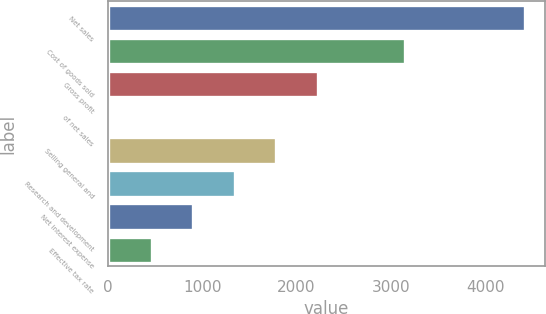Convert chart to OTSL. <chart><loc_0><loc_0><loc_500><loc_500><bar_chart><fcel>Net sales<fcel>Cost of goods sold<fcel>Gross profit<fcel>of net sales<fcel>Selling general and<fcel>Research and development<fcel>Net interest expense<fcel>Effective tax rate<nl><fcel>4416.1<fcel>3146.5<fcel>2222.4<fcel>28.7<fcel>1783.66<fcel>1344.92<fcel>906.18<fcel>467.44<nl></chart> 